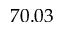<formula> <loc_0><loc_0><loc_500><loc_500>7 0 . 0 3</formula> 